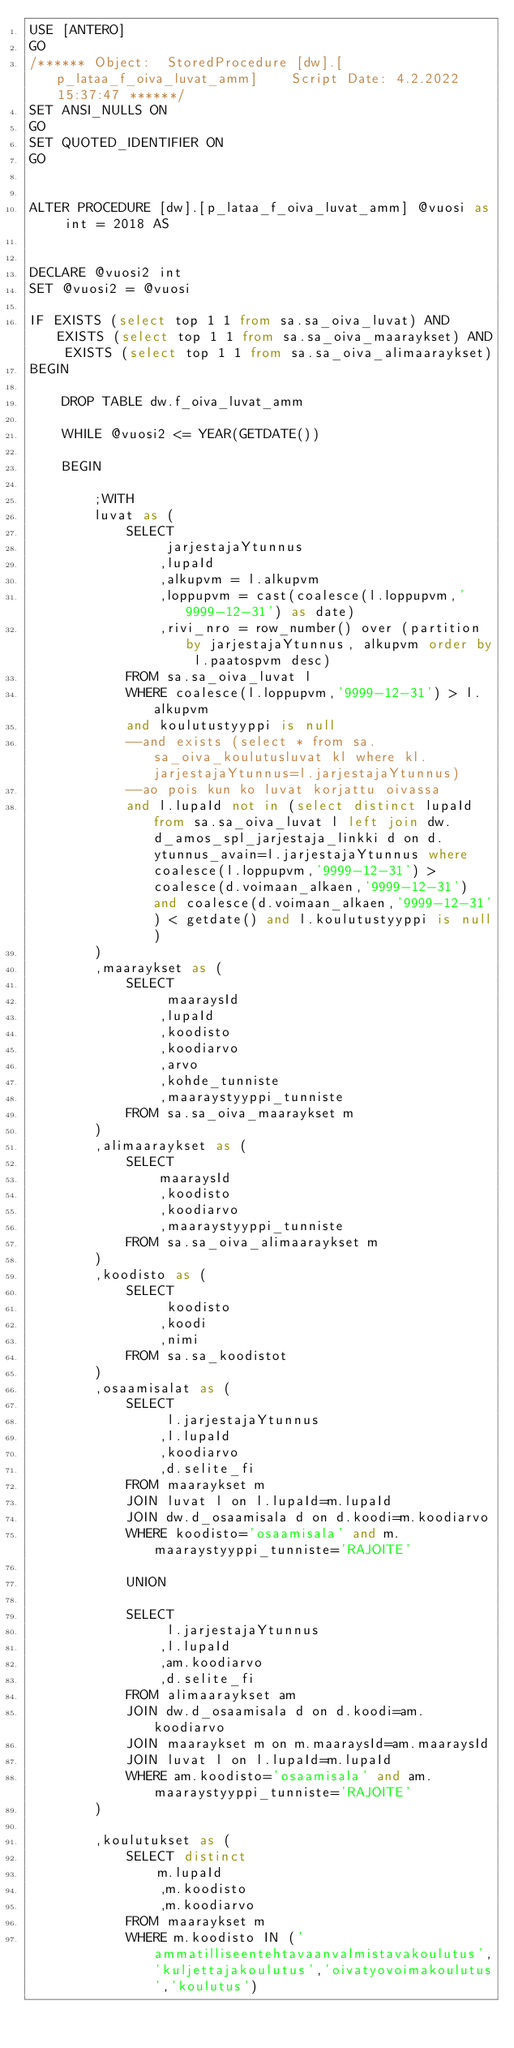<code> <loc_0><loc_0><loc_500><loc_500><_SQL_>USE [ANTERO]
GO
/****** Object:  StoredProcedure [dw].[p_lataa_f_oiva_luvat_amm]    Script Date: 4.2.2022 15:37:47 ******/
SET ANSI_NULLS ON
GO
SET QUOTED_IDENTIFIER ON
GO


ALTER PROCEDURE [dw].[p_lataa_f_oiva_luvat_amm] @vuosi as int = 2018 AS


DECLARE @vuosi2 int
SET @vuosi2 = @vuosi

IF EXISTS (select top 1 1 from sa.sa_oiva_luvat) AND EXISTS (select top 1 1 from sa.sa_oiva_maaraykset) AND EXISTS (select top 1 1 from sa.sa_oiva_alimaaraykset)
BEGIN 

	DROP TABLE dw.f_oiva_luvat_amm

	WHILE @vuosi2 <= YEAR(GETDATE())

	BEGIN

		;WITH 
		luvat as (
			SELECT 
				 jarjestajaYtunnus
				,lupaId
				,alkupvm = l.alkupvm
				,loppupvm = cast(coalesce(l.loppupvm,'9999-12-31') as date)
				,rivi_nro = row_number() over (partition by jarjestajaYtunnus, alkupvm order by l.paatospvm desc)
			FROM sa.sa_oiva_luvat l
			WHERE coalesce(l.loppupvm,'9999-12-31') > l.alkupvm
			and koulutustyyppi is null
			--and exists (select * from sa.sa_oiva_koulutusluvat kl where kl.jarjestajaYtunnus=l.jarjestajaYtunnus)
			--ao pois kun ko luvat korjattu oivassa
			and l.lupaId not in (select distinct lupaId from sa.sa_oiva_luvat l	left join dw.d_amos_spl_jarjestaja_linkki d on d.ytunnus_avain=l.jarjestajaYtunnus where coalesce(l.loppupvm,'9999-12-31') > coalesce(d.voimaan_alkaen,'9999-12-31') and coalesce(d.voimaan_alkaen,'9999-12-31') < getdate() and l.koulutustyyppi is null)
		)
		,maaraykset as (
			SELECT 
				 maaraysId
				,lupaId
				,koodisto
				,koodiarvo
				,arvo
				,kohde_tunniste
				,maaraystyyppi_tunniste
			FROM sa.sa_oiva_maaraykset m
		)
		,alimaaraykset as (
			SELECT 
				maaraysId
				,koodisto
				,koodiarvo
				,maaraystyyppi_tunniste
			FROM sa.sa_oiva_alimaaraykset m
		)
		,koodisto as (
			SELECT 
				 koodisto
				,koodi
				,nimi
			FROM sa.sa_koodistot
		)
		,osaamisalat as (
			SELECT
				 l.jarjestajaYtunnus
				,l.lupaId
				,koodiarvo
				,d.selite_fi
			FROM maaraykset m
			JOIN luvat l on l.lupaId=m.lupaId
			JOIN dw.d_osaamisala d on d.koodi=m.koodiarvo
			WHERE koodisto='osaamisala' and m.maaraystyyppi_tunniste='RAJOITE'

			UNION

			SELECT
				 l.jarjestajaYtunnus
				,l.lupaId
				,am.koodiarvo
				,d.selite_fi
			FROM alimaaraykset am
			JOIN dw.d_osaamisala d on d.koodi=am.koodiarvo
			JOIN maaraykset m on m.maaraysId=am.maaraysId
			JOIN luvat l on l.lupaId=m.lupaId
			WHERE am.koodisto='osaamisala' and am.maaraystyyppi_tunniste='RAJOITE'
		)

		,koulutukset as (
			SELECT distinct 
				m.lupaId
				,m.koodisto
				,m.koodiarvo 
			FROM maaraykset m
			WHERE m.koodisto IN ('ammatilliseentehtavaanvalmistavakoulutus','kuljettajakoulutus','oivatyovoimakoulutus','koulutus')</code> 